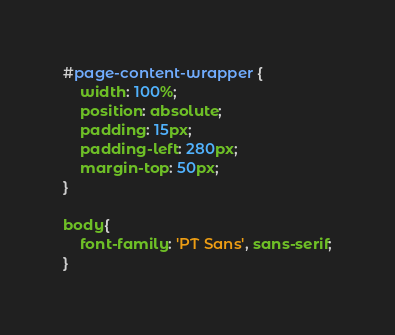<code> <loc_0><loc_0><loc_500><loc_500><_CSS_>#page-content-wrapper {
    width: 100%;
    position: absolute;
    padding: 15px;
    padding-left: 280px;
    margin-top: 50px;
}

body{
	font-family: 'PT Sans', sans-serif;
}</code> 